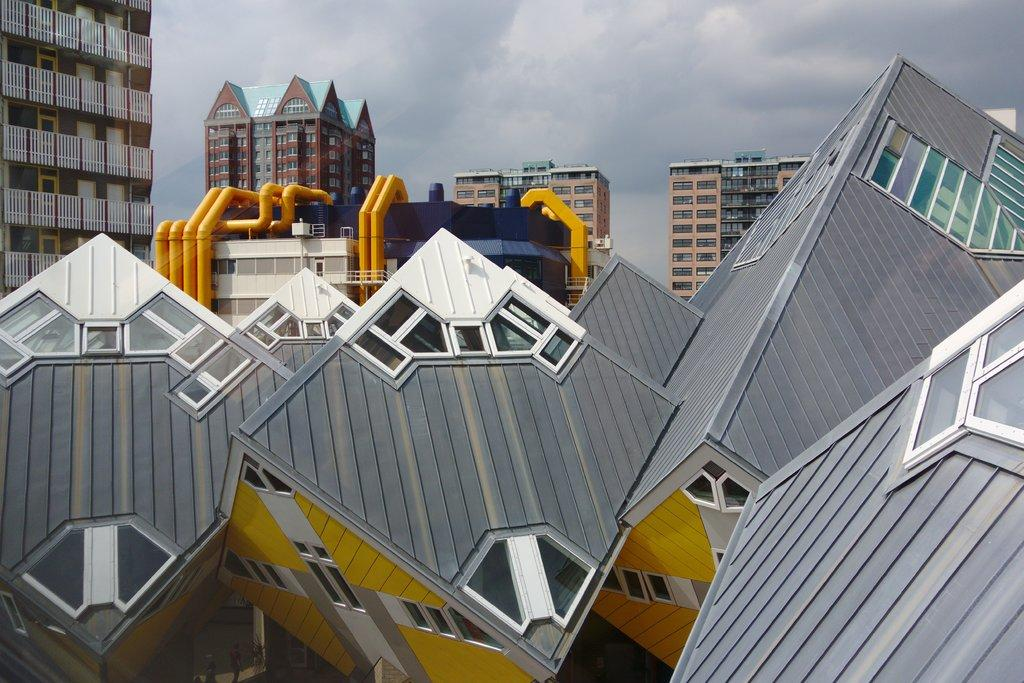What type of structures can be seen in the image? There are buildings in the image. What is the condition of the sky in the image? The sky is cloudy in the image. Can you see any swings in the image? There are no swings present in the image. How many wings can be seen on the buildings in the image? The buildings in the image do not have wings; they are stationary structures. 